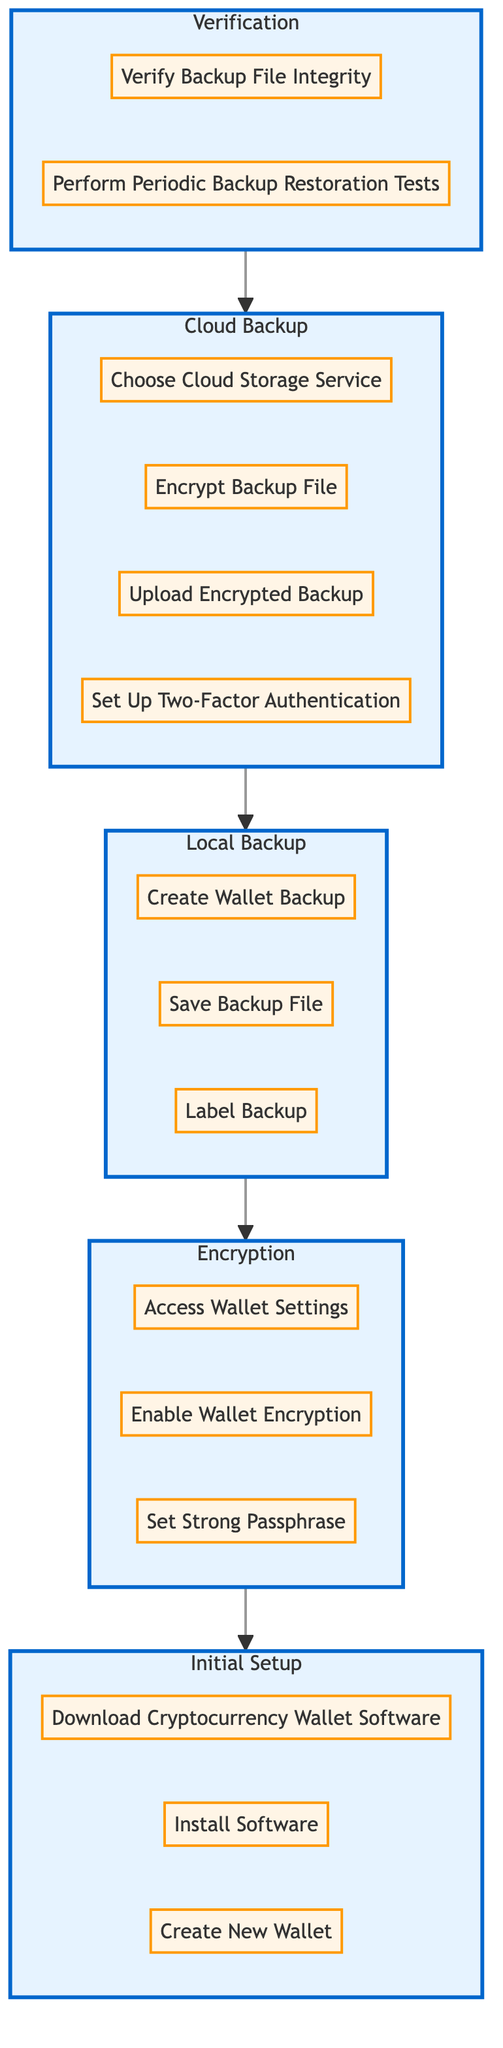What is the first action in the Initial Setup stage? The first action listed under the Initial Setup stage is "Download Cryptocurrency Wallet Software." This can be found at the top of the diagram where the Initial Setup stage is defined.
Answer: Download Cryptocurrency Wallet Software How many stages are there in the diagram? The diagram contains five distinct stages: Initial Setup, Encryption, Local Backup, Cloud Backup, and Verification. Each stage is clearly defined as a subgraph in the flowchart.
Answer: Five stages What follows after the Cloud Backup stage? After the Cloud Backup stage, the diagram indicates the flow leads to the Verification stage. This can be traced in the sequence from Cloud Backup flowing upward to Verification.
Answer: Verification Which tool is mentioned for encrypting the backup file? The tools mentioned for encrypting the backup file are 7-Zip or VeraCrypt, which are listed in the actions of the Cloud Backup stage.
Answer: 7-Zip or VeraCrypt What is recommended for setting a strong passphrase during the Encryption stage? The recommendation for setting a strong passphrase is to use a combination of upper/lower case letters, numbers, and symbols, specified under the actions in the Encryption stage.
Answer: Use a combination of upper/lower case letters, numbers, and symbols Which action comes just before the "Create Wallet Backup" action? The "Create Wallet Backup" action is preceded by the action "Set Strong Passphrase" in the Encryption stage. By following the flow from Encryption to Local Backup, you can identify this order.
Answer: Set Strong Passphrase What is necessary to ensure backup file integrity during Verification? During Verification, it is necessary to "Verify Backup File Integrity," which is the first action listed under the Verification stage in the diagram.
Answer: Verify Backup File Integrity How does the flow of the diagram move from Encryption to Initial Setup? The flow moves upward from the Encryption stage back to the Initial Setup stage. This expresses that the process should follow the sequence from initial setup to encryption, clearly indicating the reverse path through the diagram.
Answer: Upward flow from Encryption to Initial Setup 